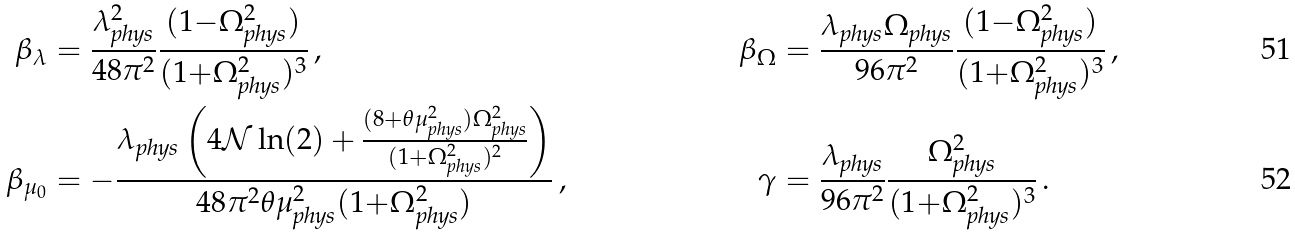<formula> <loc_0><loc_0><loc_500><loc_500>\beta _ { \lambda } & = \frac { \lambda _ { \text {phys} } ^ { 2 } } { 4 8 \pi ^ { 2 } } \frac { ( 1 { - } \Omega _ { \text {phys} } ^ { 2 } ) } { ( 1 { + } \Omega _ { \text {phys} } ^ { 2 } ) ^ { 3 } } \, , & \beta _ { \Omega } & = \frac { \lambda _ { \text {phys} } \Omega _ { \text {phys} } } { 9 6 \pi ^ { 2 } } \frac { ( 1 { - } \Omega _ { \text {phys} } ^ { 2 } ) } { ( 1 { + } \Omega _ { \text {phys} } ^ { 2 } ) ^ { 3 } } \, , \\ \beta _ { \mu _ { 0 } } & = - \frac { \lambda _ { \text {phys} } \left ( 4 \mathcal { N } \ln ( 2 ) + \frac { ( 8 { + } \theta \mu _ { \text {phys} } ^ { 2 } ) \Omega ^ { 2 } _ { \text {phys} } } { ( 1 { + } \Omega _ { \text {phys} } ^ { 2 } ) ^ { 2 } } \right ) } { 4 8 \pi ^ { 2 } \theta \mu _ { \text {phys} } ^ { 2 } ( 1 { + } \Omega _ { \text {phys} } ^ { 2 } ) } \, , & \gamma & = \frac { \lambda _ { \text {phys} } } { 9 6 \pi ^ { 2 } } \frac { \Omega ^ { 2 } _ { \text {phys} } } { ( 1 { + } \Omega _ { \text {phys} } ^ { 2 } ) ^ { 3 } } \, .</formula> 